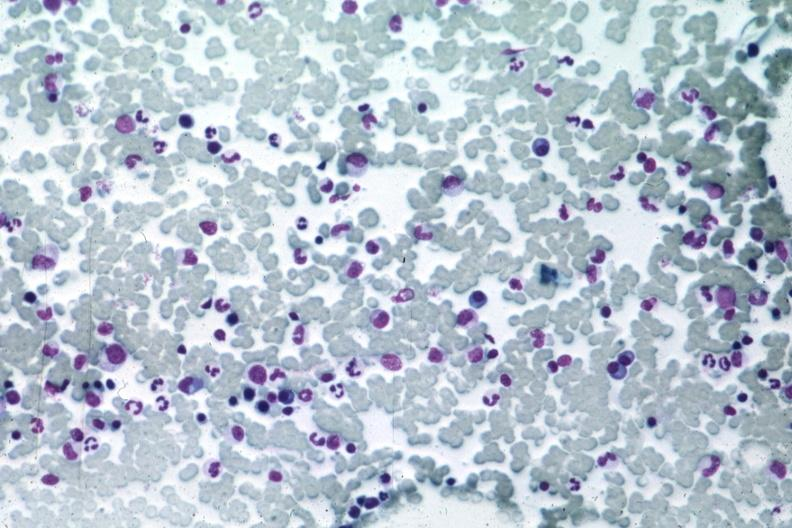what is present?
Answer the question using a single word or phrase. Bone marrow 